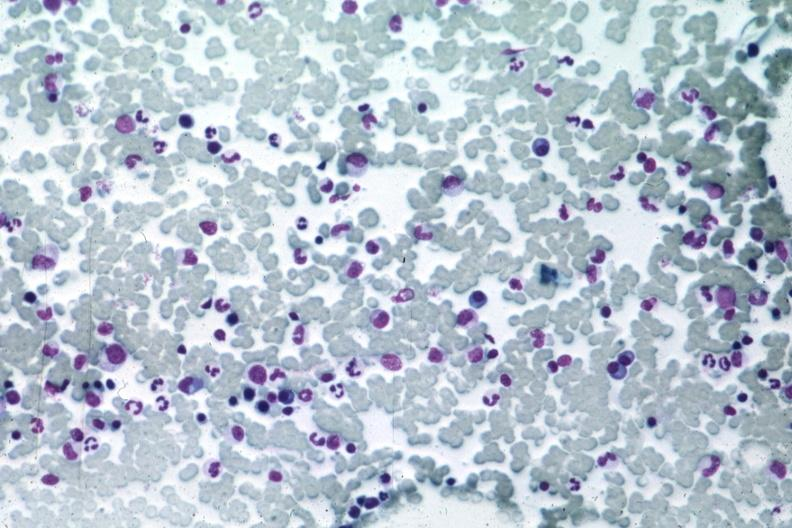what is present?
Answer the question using a single word or phrase. Bone marrow 